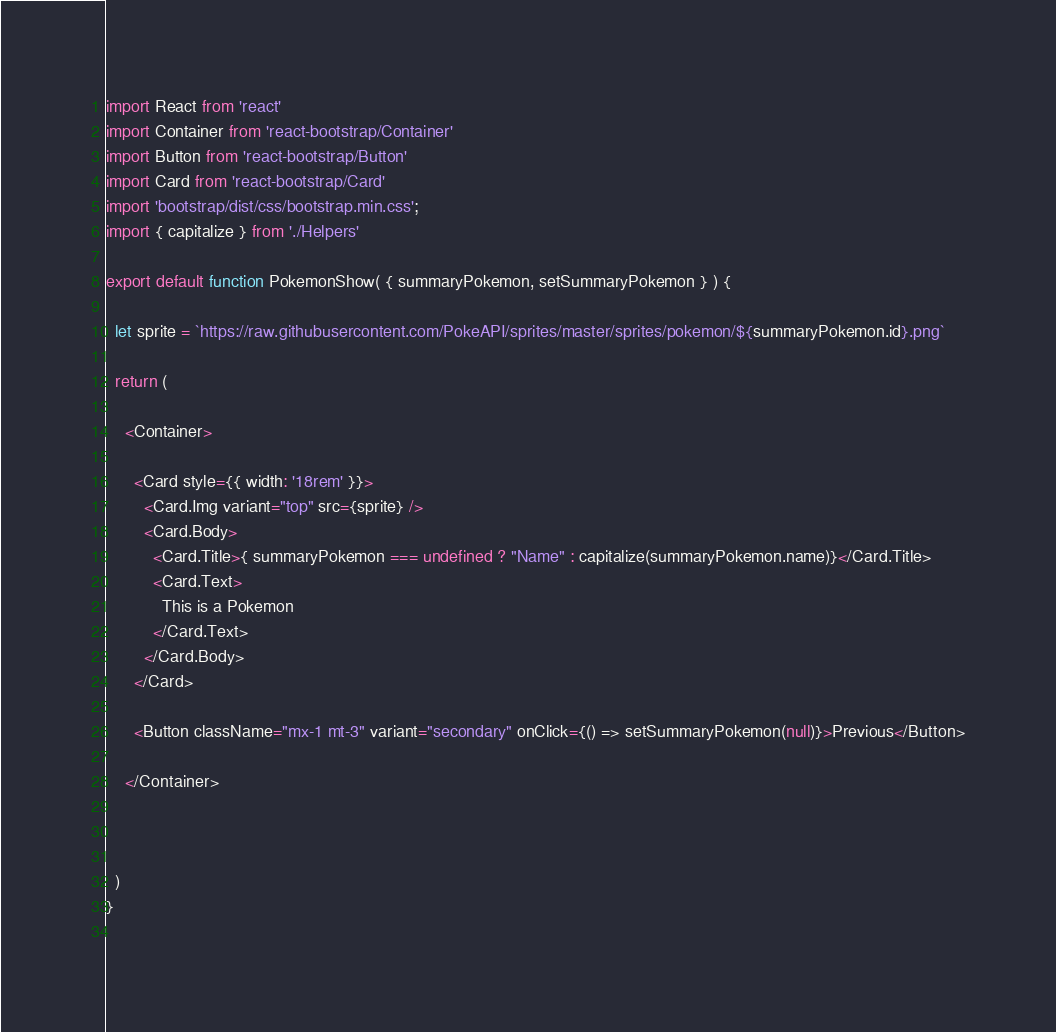<code> <loc_0><loc_0><loc_500><loc_500><_JavaScript_>
import React from 'react'
import Container from 'react-bootstrap/Container'
import Button from 'react-bootstrap/Button'
import Card from 'react-bootstrap/Card'
import 'bootstrap/dist/css/bootstrap.min.css';
import { capitalize } from './Helpers'

export default function PokemonShow( { summaryPokemon, setSummaryPokemon } ) {

  let sprite = `https://raw.githubusercontent.com/PokeAPI/sprites/master/sprites/pokemon/${summaryPokemon.id}.png` 

  return (

    <Container>

      <Card style={{ width: '18rem' }}>
        <Card.Img variant="top" src={sprite} />
        <Card.Body>
          <Card.Title>{ summaryPokemon === undefined ? "Name" : capitalize(summaryPokemon.name)}</Card.Title>
          <Card.Text>
            This is a Pokemon
          </Card.Text>
        </Card.Body>
      </Card>

      <Button className="mx-1 mt-3" variant="secondary" onClick={() => setSummaryPokemon(null)}>Previous</Button>

    </Container> 



  )
}
 </code> 